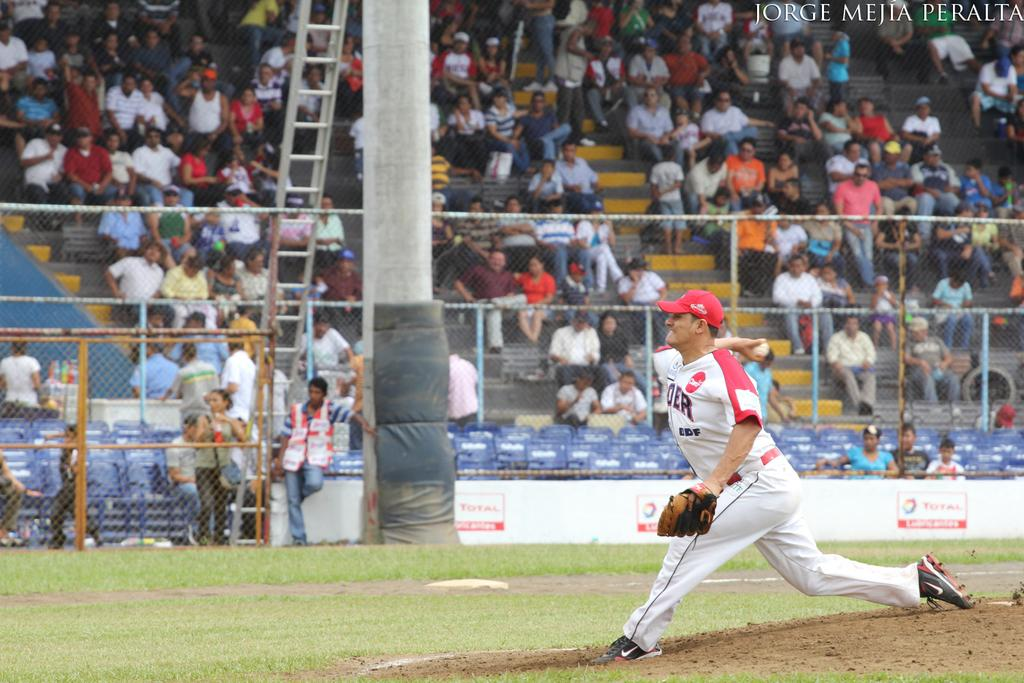<image>
Relay a brief, clear account of the picture shown. a jorge mejia peralta photograph of a baseball game 